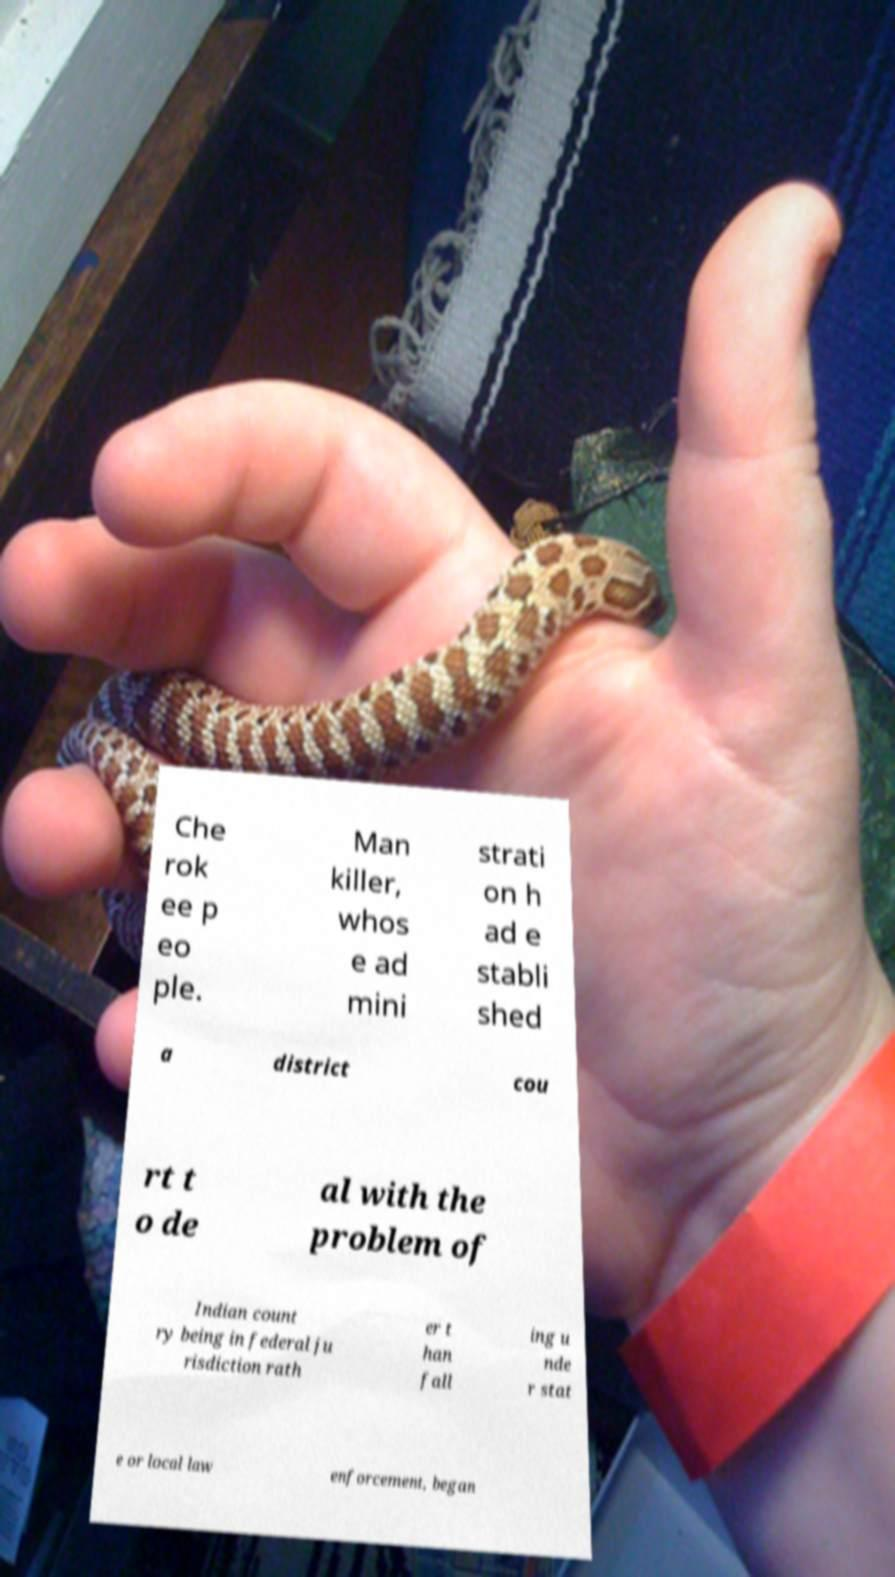Could you extract and type out the text from this image? Che rok ee p eo ple. Man killer, whos e ad mini strati on h ad e stabli shed a district cou rt t o de al with the problem of Indian count ry being in federal ju risdiction rath er t han fall ing u nde r stat e or local law enforcement, began 